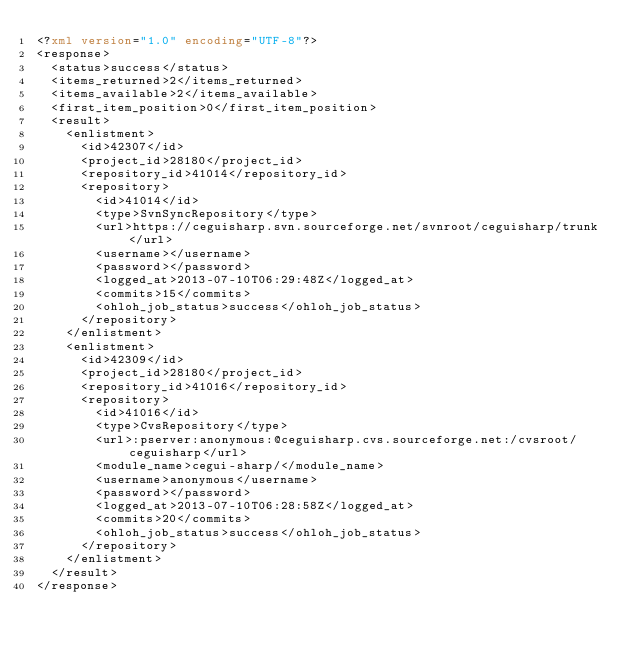Convert code to text. <code><loc_0><loc_0><loc_500><loc_500><_XML_><?xml version="1.0" encoding="UTF-8"?>
<response>
  <status>success</status>
  <items_returned>2</items_returned>
  <items_available>2</items_available>
  <first_item_position>0</first_item_position>
  <result>
    <enlistment>
      <id>42307</id>
      <project_id>28180</project_id>
      <repository_id>41014</repository_id>
      <repository>
        <id>41014</id>
        <type>SvnSyncRepository</type>
        <url>https://ceguisharp.svn.sourceforge.net/svnroot/ceguisharp/trunk</url>
        <username></username>
        <password></password>
        <logged_at>2013-07-10T06:29:48Z</logged_at>
        <commits>15</commits>
        <ohloh_job_status>success</ohloh_job_status>
      </repository>
    </enlistment>
    <enlistment>
      <id>42309</id>
      <project_id>28180</project_id>
      <repository_id>41016</repository_id>
      <repository>
        <id>41016</id>
        <type>CvsRepository</type>
        <url>:pserver:anonymous:@ceguisharp.cvs.sourceforge.net:/cvsroot/ceguisharp</url>
        <module_name>cegui-sharp/</module_name>
        <username>anonymous</username>
        <password></password>
        <logged_at>2013-07-10T06:28:58Z</logged_at>
        <commits>20</commits>
        <ohloh_job_status>success</ohloh_job_status>
      </repository>
    </enlistment>
  </result>
</response>
</code> 